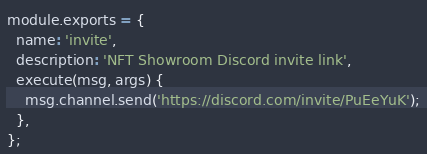Convert code to text. <code><loc_0><loc_0><loc_500><loc_500><_JavaScript_>module.exports = {
  name: 'invite',
  description: 'NFT Showroom Discord invite link',
  execute(msg, args) {
    msg.channel.send('https://discord.com/invite/PuEeYuK');
  },
};
</code> 